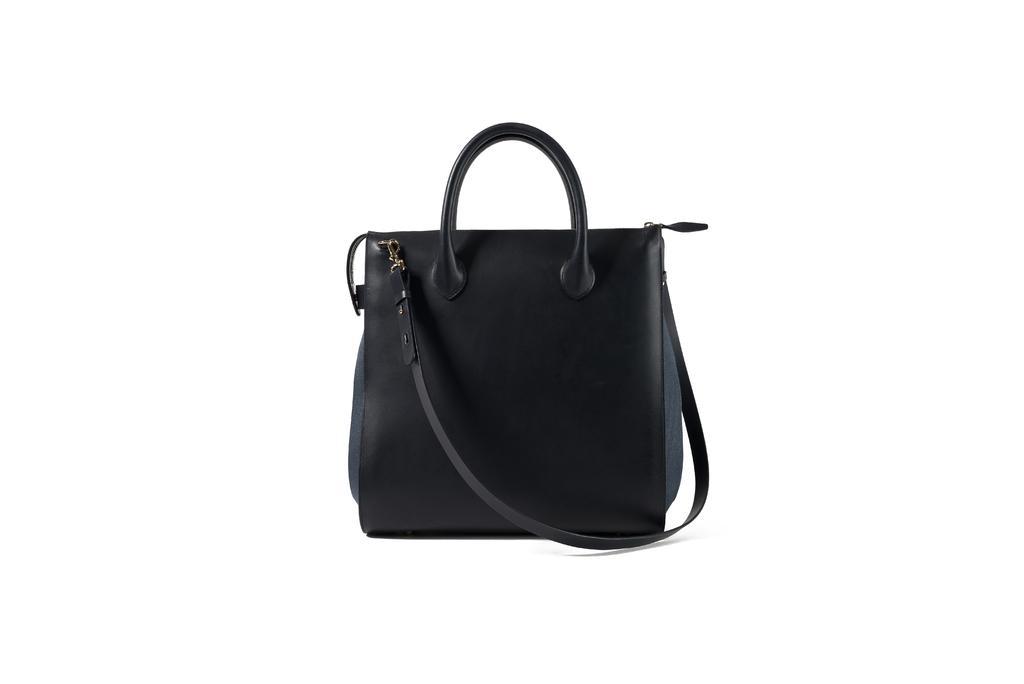Can you describe this image briefly? In the image there is a black handbag and the background is white. 